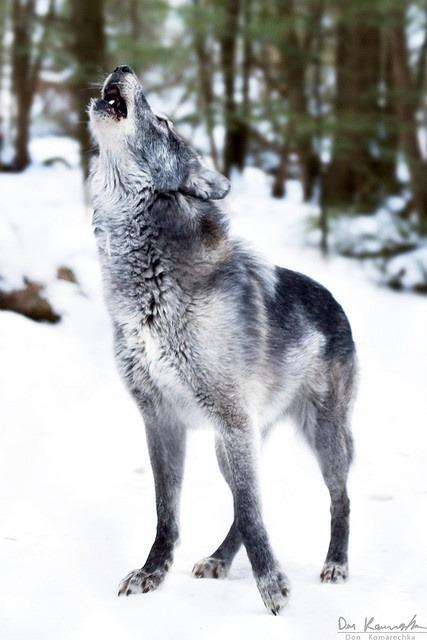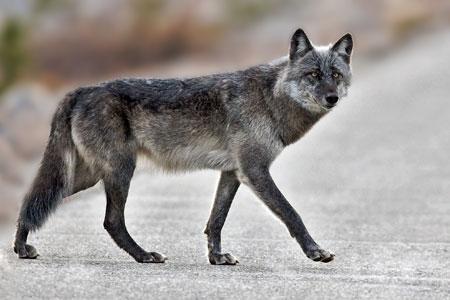The first image is the image on the left, the second image is the image on the right. Evaluate the accuracy of this statement regarding the images: "There are no more than two wolves standing outside.". Is it true? Answer yes or no. Yes. 